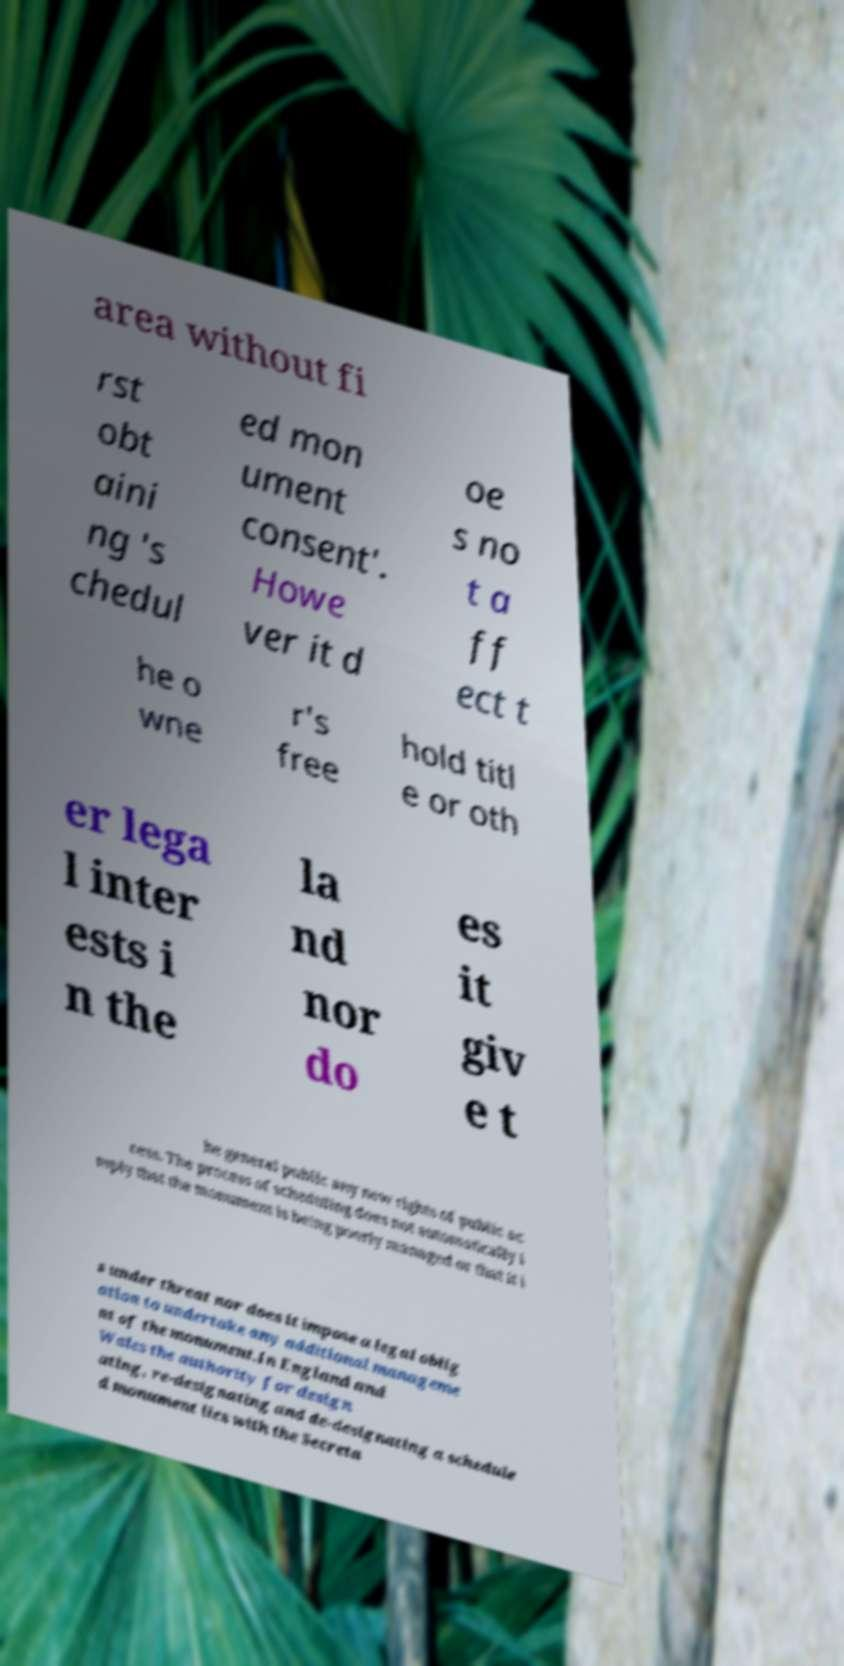Can you read and provide the text displayed in the image?This photo seems to have some interesting text. Can you extract and type it out for me? area without fi rst obt aini ng 's chedul ed mon ument consent'. Howe ver it d oe s no t a ff ect t he o wne r's free hold titl e or oth er lega l inter ests i n the la nd nor do es it giv e t he general public any new rights of public ac cess. The process of scheduling does not automatically i mply that the monument is being poorly managed or that it i s under threat nor does it impose a legal oblig ation to undertake any additional manageme nt of the monument.In England and Wales the authority for design ating, re-designating and de-designating a schedule d monument lies with the Secreta 